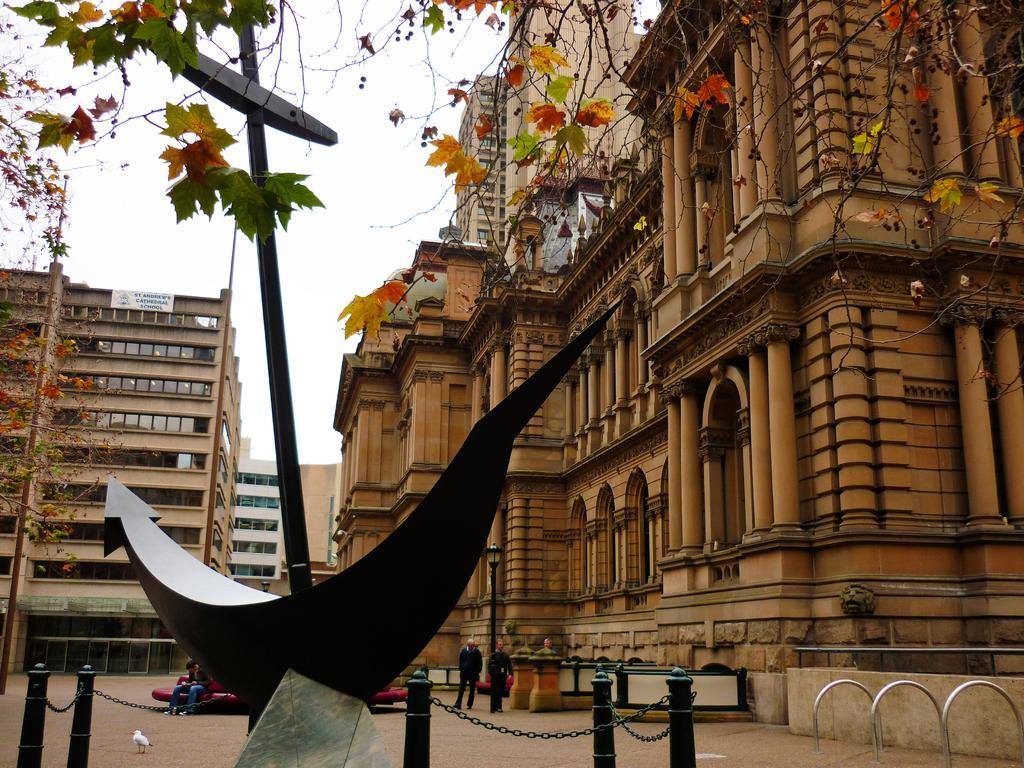Could you give a brief overview of what you see in this image? In this image, we can see buildings, pillars, walls, glass windows, banner, trees. At the bottom, we can see platform, rods, poles with chains, some object. Here we can see a bird. Background we can see few people. 